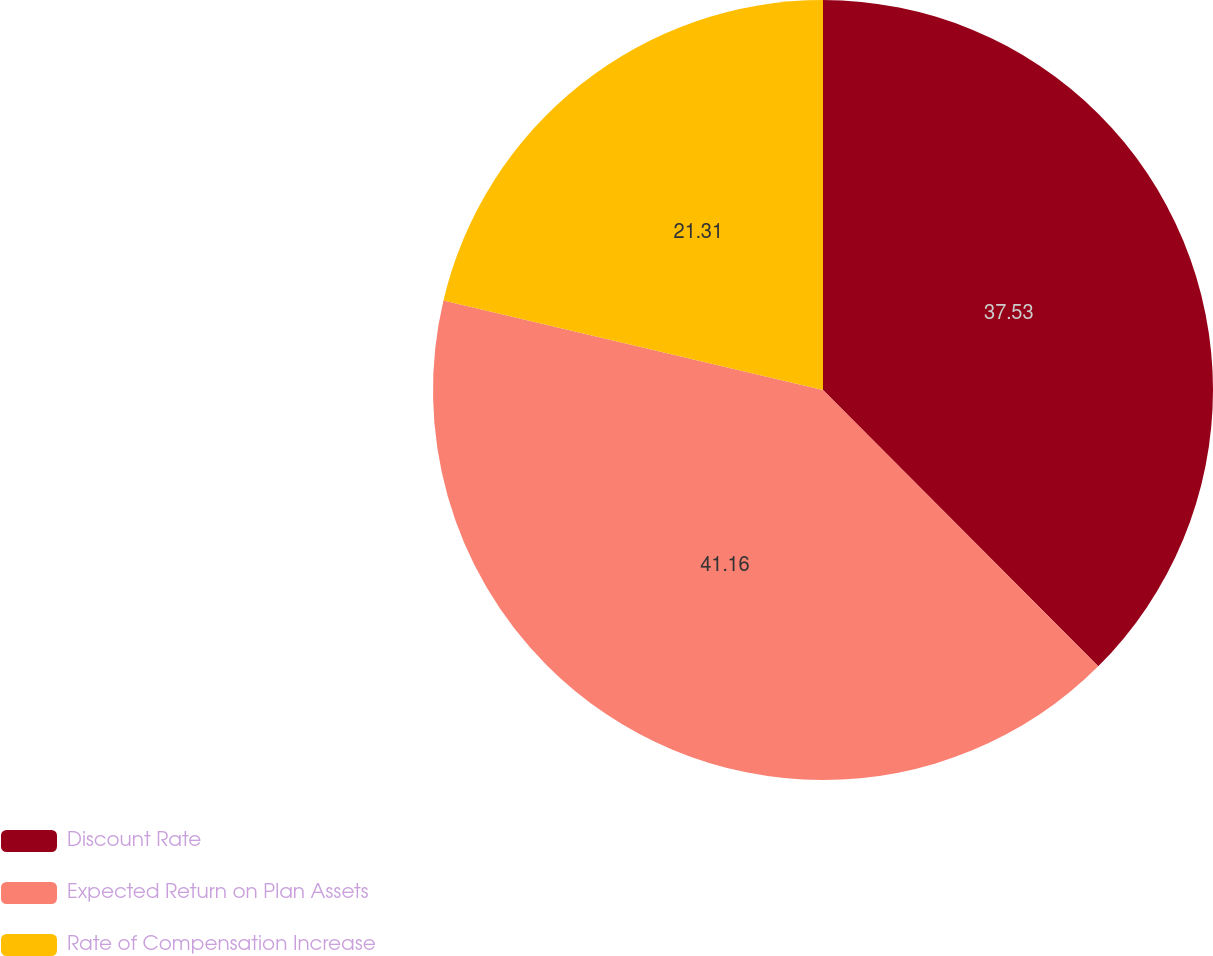Convert chart. <chart><loc_0><loc_0><loc_500><loc_500><pie_chart><fcel>Discount Rate<fcel>Expected Return on Plan Assets<fcel>Rate of Compensation Increase<nl><fcel>37.53%<fcel>41.16%<fcel>21.31%<nl></chart> 